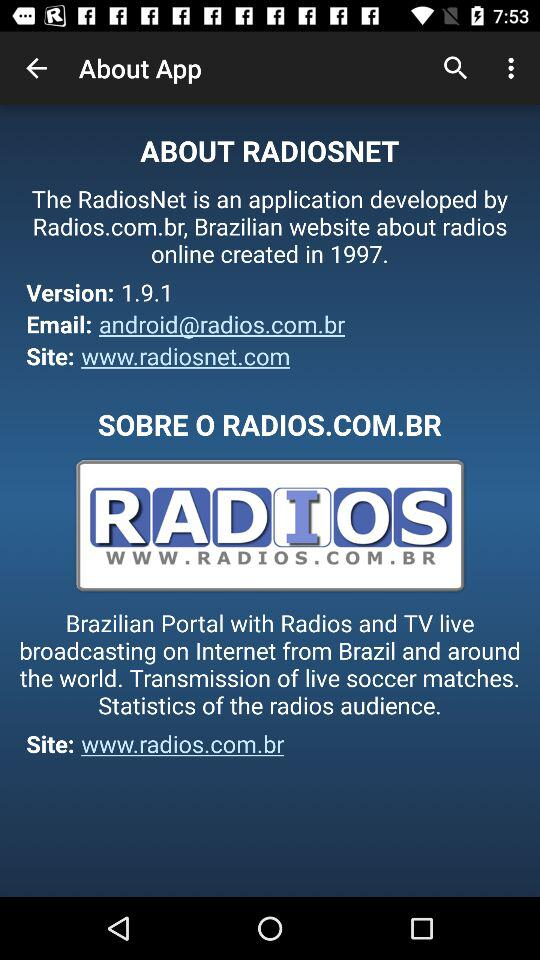Who developed "RADIOSNET"? "RADIOSNET" was developed by "Radios.com.br". 